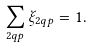<formula> <loc_0><loc_0><loc_500><loc_500>\sum _ { 2 q p } \xi _ { 2 q p } = 1 .</formula> 